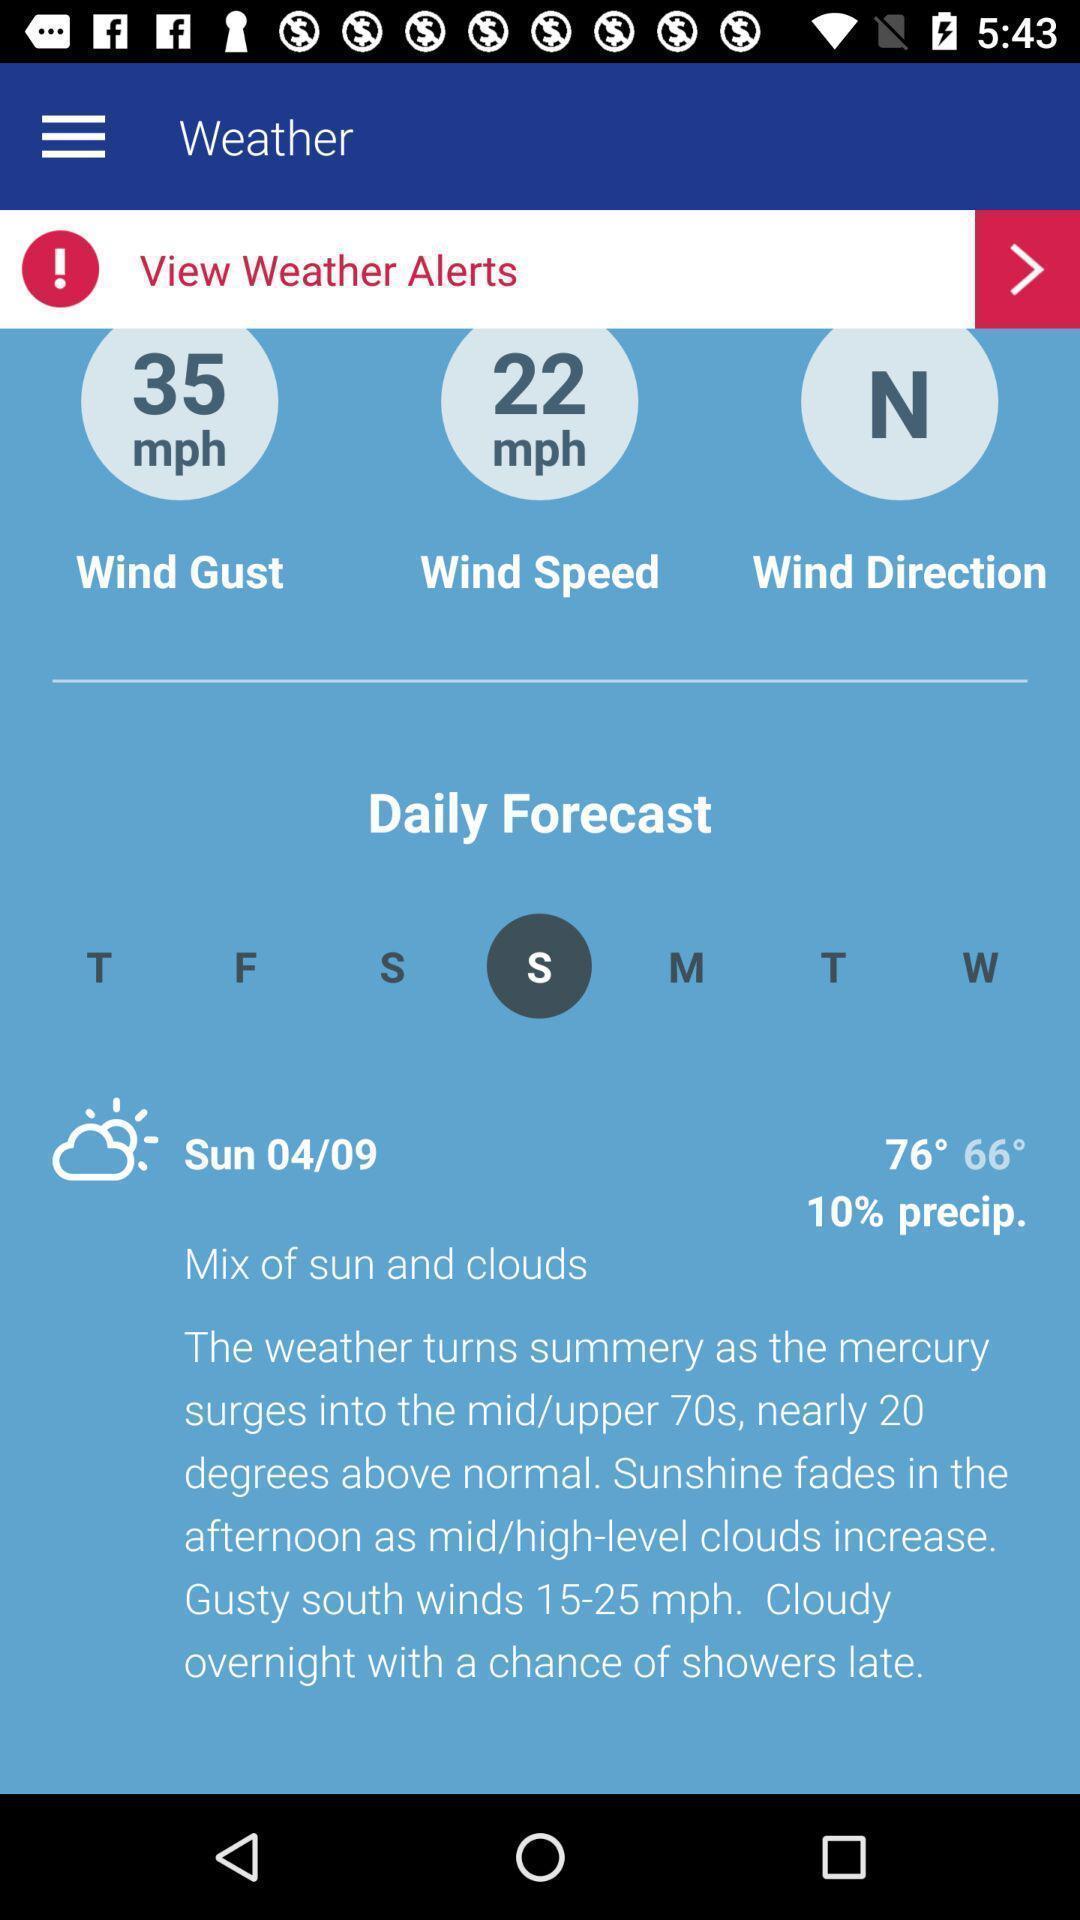Explain what's happening in this screen capture. Screen shows weather alerts in weather app. 